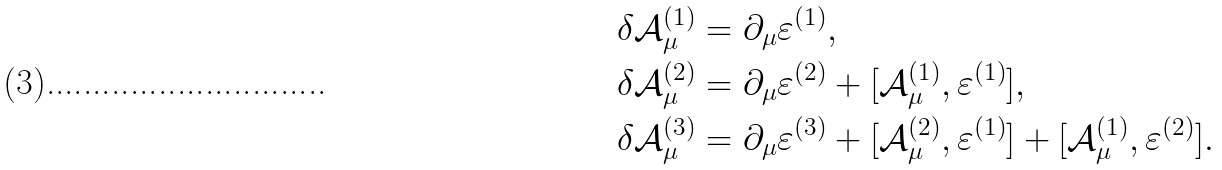<formula> <loc_0><loc_0><loc_500><loc_500>\delta \mathcal { A } _ { \mu } ^ { ( 1 ) } & = \partial _ { \mu } \varepsilon ^ { ( 1 ) } , \\ \delta \mathcal { A } _ { \mu } ^ { ( 2 ) } & = \partial _ { \mu } \varepsilon ^ { ( 2 ) } + [ \mathcal { A } _ { \mu } ^ { ( 1 ) } , \varepsilon ^ { ( 1 ) } ] , \\ \delta \mathcal { A } _ { \mu } ^ { ( 3 ) } & = \partial _ { \mu } \varepsilon ^ { ( 3 ) } + [ \mathcal { A } _ { \mu } ^ { ( 2 ) } , \varepsilon ^ { ( 1 ) } ] + [ \mathcal { A } _ { \mu } ^ { ( 1 ) } , \varepsilon ^ { ( 2 ) } ] .</formula> 